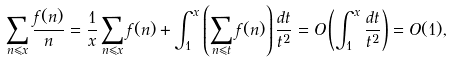Convert formula to latex. <formula><loc_0><loc_0><loc_500><loc_500>\sum _ { n \leqslant x } \frac { f ( n ) } { n } = \frac { 1 } { x } \sum _ { n \leqslant x } f ( n ) + \int _ { 1 } ^ { x } \left ( \sum _ { n \leqslant t } f ( n ) \right ) \frac { d t } { t ^ { 2 } } = O \left ( \int _ { 1 } ^ { x } \frac { d t } { t ^ { 2 } } \right ) = O ( 1 ) ,</formula> 